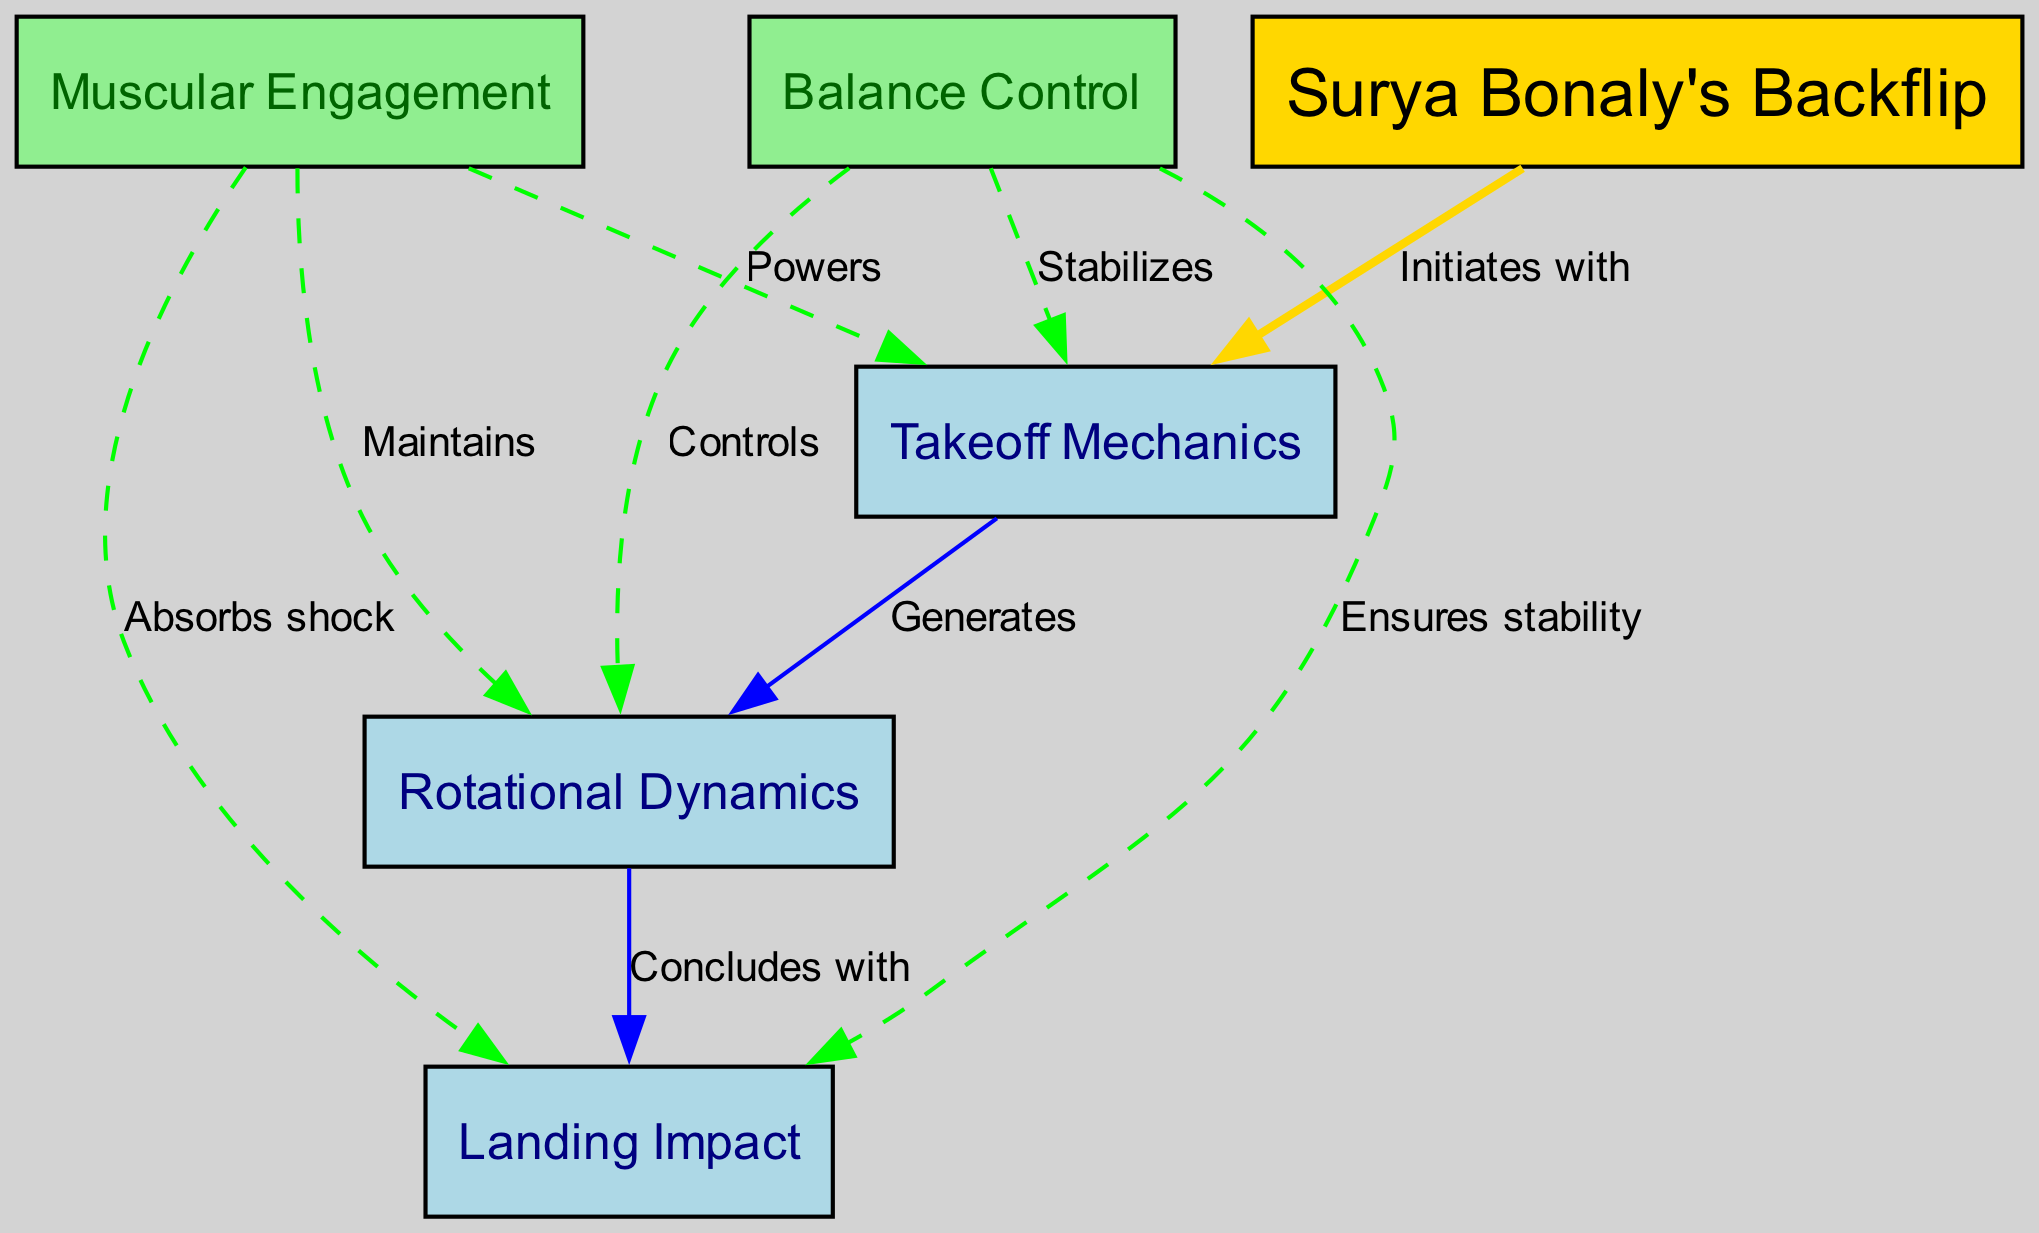What is the main technique illustrated in the diagram? The diagram centers around "Surya Bonaly's Backflip", which is identified as the main node in the visualization.
Answer: Surya Bonaly's Backflip How many nodes are present in the diagram? The diagram includes six nodes: Surya Bonaly's Backflip, Takeoff Mechanics, Rotational Dynamics, Landing Impact, Muscular Engagement, and Balance Control. Thus, the total count is determined to be six.
Answer: 6 What label describes the relationship between Takeoff Mechanics and Rotational Dynamics? According to the edge connecting these two nodes, the relationship is described as "Generates," indicating that Takeoff Mechanics leads into Rotational Dynamics.
Answer: Generates Which node absorbs shock during the landing phase? The edge connecting the Muscular Engagement node to Landing Impact indicates that the muscular engagement is responsible for "Absorbs shock", identifying it as the node that performs this function.
Answer: Absorbs shock How do Balance Control and Landing Impact relate? The relationship is shown with the edge labeled "Ensures stability," revealing that the Balance Control node is crucial for maintaining stability during the landing phase, demonstrating its interconnectedness with Landing Impact.
Answer: Ensures stability What color are the nodes representing Takeoff Mechanics, Rotational Dynamics, and Landing Impact? All three nodes are filled with light blue color, differentiating them from muscular engagement and balance control nodes which have different colors.
Answer: Light blue Which node stabilizes the Takeoff Mechanics? The edge from the Balance Control node indicates that it "Stabilizes" the Takeoff Mechanics, showcasing its role in assisting the initial action of the backflip.
Answer: Stabilizes How many edges connect to the Landing Impact node? The Landing Impact node has three incoming edges: one from Rotational Dynamics, one from Muscular Engagement, and one from Balance Control. Thus, the total number of edges leading to it is three.
Answer: 3 What is the purpose of muscular engagement in relation to rotation? The diagram shows that muscular engagement "Maintains" the Rotational Dynamics, indicating its critical role in sustaining the rotation during the backflip.
Answer: Maintains 